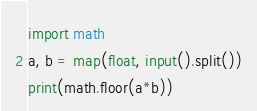<code> <loc_0><loc_0><loc_500><loc_500><_Python_>import math
a, b = map(float, input().split())
print(math.floor(a*b))</code> 